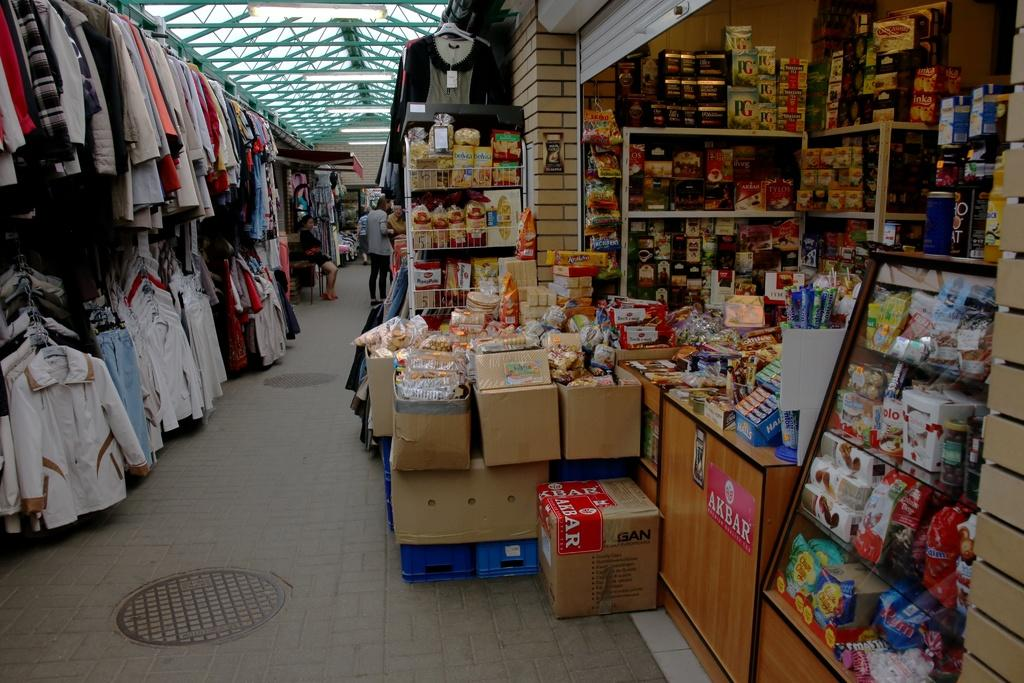<image>
Give a short and clear explanation of the subsequent image. a store that seems to sell lots of things, has an AKbar sign 